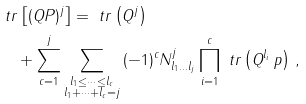<formula> <loc_0><loc_0><loc_500><loc_500>& \ t r \left [ ( Q P ) ^ { j } \right ] = \ t r \left ( Q ^ { j } \right ) \\ & \quad + \sum _ { c = 1 } ^ { j } \sum _ { \substack { l _ { 1 } \leq \dots \leq l _ { c } \\ l _ { 1 } + \dots + l _ { c } = j } } \, ( - 1 ) ^ { c } N ^ { j } _ { l _ { 1 } \dots l _ { j } } \prod _ { i = 1 } ^ { c } \ t r \left ( Q ^ { l _ { i } } \, p \right ) \, ,</formula> 